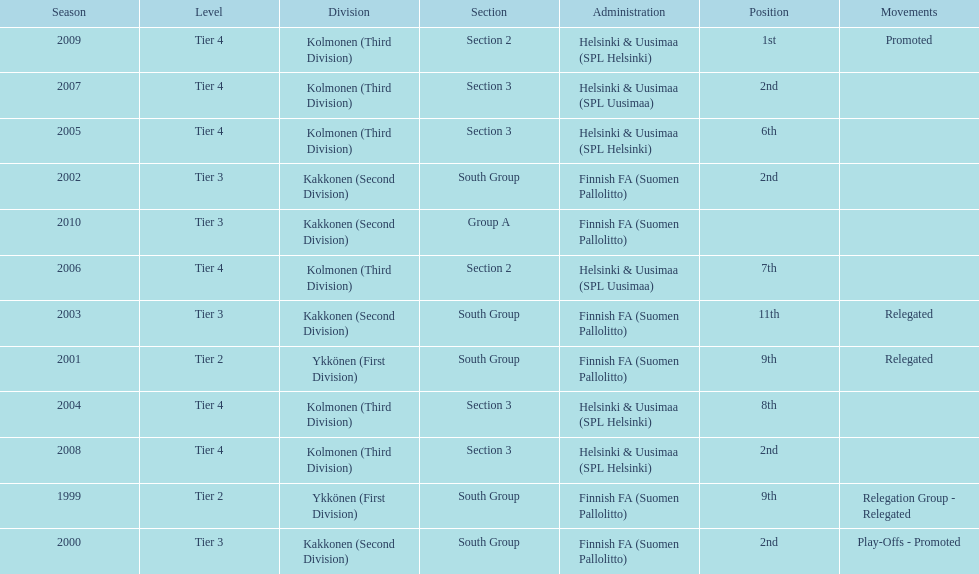Of the third division, how many were in section3? 4. 